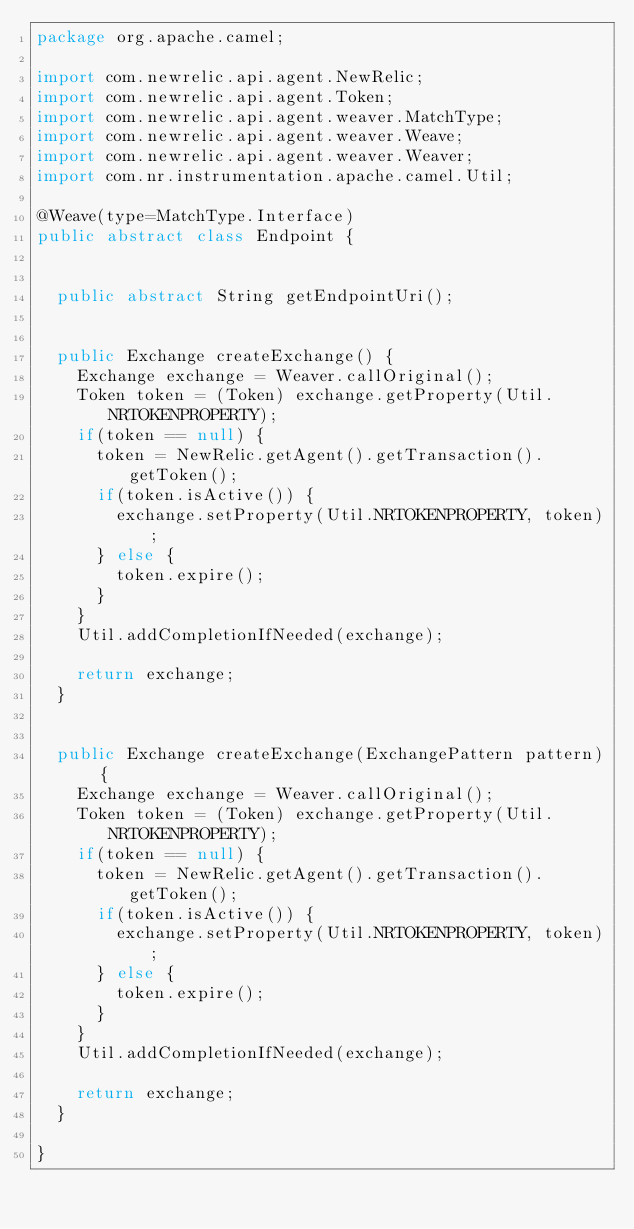Convert code to text. <code><loc_0><loc_0><loc_500><loc_500><_Java_>package org.apache.camel;

import com.newrelic.api.agent.NewRelic;
import com.newrelic.api.agent.Token;
import com.newrelic.api.agent.weaver.MatchType;
import com.newrelic.api.agent.weaver.Weave;
import com.newrelic.api.agent.weaver.Weaver;
import com.nr.instrumentation.apache.camel.Util;

@Weave(type=MatchType.Interface)
public abstract class Endpoint {

	
	public abstract String getEndpointUri();
	
	
	public Exchange createExchange() {
		Exchange exchange = Weaver.callOriginal();
		Token token = (Token) exchange.getProperty(Util.NRTOKENPROPERTY);
		if(token == null) {
			token = NewRelic.getAgent().getTransaction().getToken();
			if(token.isActive()) {
				exchange.setProperty(Util.NRTOKENPROPERTY, token);
			} else {
				token.expire();
			}
		}
		Util.addCompletionIfNeeded(exchange);
		
		return exchange;
	}
	
	
	public Exchange createExchange(ExchangePattern pattern) {
		Exchange exchange = Weaver.callOriginal();
		Token token = (Token) exchange.getProperty(Util.NRTOKENPROPERTY);
		if(token == null) {
			token = NewRelic.getAgent().getTransaction().getToken();
			if(token.isActive()) {
				exchange.setProperty(Util.NRTOKENPROPERTY, token);
			} else {
				token.expire();
			}
		}
		Util.addCompletionIfNeeded(exchange);
		
		return exchange;
	}

}
</code> 